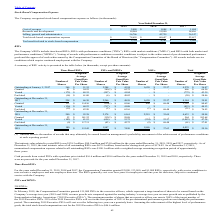From Monolithic Power Systems's financial document, What was the Weighted-Average Grant Date Fair Value Per Share for Time-Based RSUs and MSUs outstanding at January 1, 2017? The document shows two values: 51.35 and 23.57. From the document: "January 1, 2017 366 $ 51.35 2,284 $ 43.24 1,620 $ 23.57 4,270 $ 36.47 Outstanding at January 1, 2017 366 $ 51.35 2,284 $ 43.24 1,620 $ 23.57 4,270 $ 3..." Also, How many shares of PSUs and MPSUs, and Time-Based RSUs does the company have Outstanding at December 31, 2018 respectively? The document shows two values: 2,174 and 240 (in thousands). From the document: "Outstanding at December 31, 2018 240 $ 95.38 2,174 $ 61.61 2,219 $ 35.69 4,633 $ 50.94 Outstanding at December 31, 2018 240 $ 95.38 2,174 $ 61.61 2,21..." Also, What was the intrinsic value related to vested RSUs for the year ended December 31, 2018? According to the financial document, $90.0 million. The relevant text states: "c value related to vested RSUs was $138.3 million, $90.0 million and $74.0 million for the years ended December 31, 2019, 2018 and 2017, respectively. As of December..." Also, can you calculate: What was the percentage change in Number of shares of PSUs and MPSUs Outstanding at December 31, 2017 to December 31, 2018? To answer this question, I need to perform calculations using the financial data. The calculation is: (2,174-2,266)/2,266, which equals -4.06 (percentage). This is based on the information: "Outstanding at December 31, 2017 258 $ 66.30 2,266 $ 48.59 1,620 $ 23.57 4,144 $ 39.91 Outstanding at December 31, 2018 240 $ 95.38 2,174 $ 61.61 2,219 $ 35.69 4,633 $ 50.94..." The key data points involved are: 2,174, 2,266. Also, From 2017 to 2019, for how many years was the intrinsic value related to vested RSUs more than $80 million? Counting the relevant items in the document: $138.3 million, $90.0 million, I find 2 instances. The key data points involved are: $138.3 million, $90.0 million. Additionally, At which point of time time were there the most total shares outstanding? According to the financial document, December 31, 2018. The relevant text states: "Outstanding at December 31, 2018 240 $ 95.38 2,174 $ 61.61 2,219 $ 35.69 4,633 $ 50.94..." 